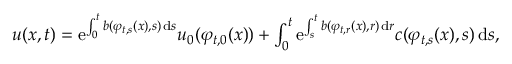<formula> <loc_0><loc_0><loc_500><loc_500>\begin{array} { r } { u ( x , t ) = e ^ { \int _ { 0 } ^ { t } b ( \varphi _ { t , s } ( x ) , s ) \, d s } u _ { 0 } ( \varphi _ { t , 0 } ( x ) ) + \int _ { 0 } ^ { t } e ^ { \int _ { s } ^ { t } b ( \varphi _ { t , r } ( x ) , r ) \, d r } c ( \varphi _ { t , s } ( x ) , s ) \, d s , } \end{array}</formula> 